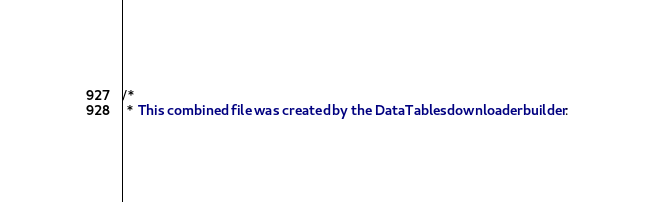Convert code to text. <code><loc_0><loc_0><loc_500><loc_500><_CSS_>/*
 * This combined file was created by the DataTables downloader builder:</code> 